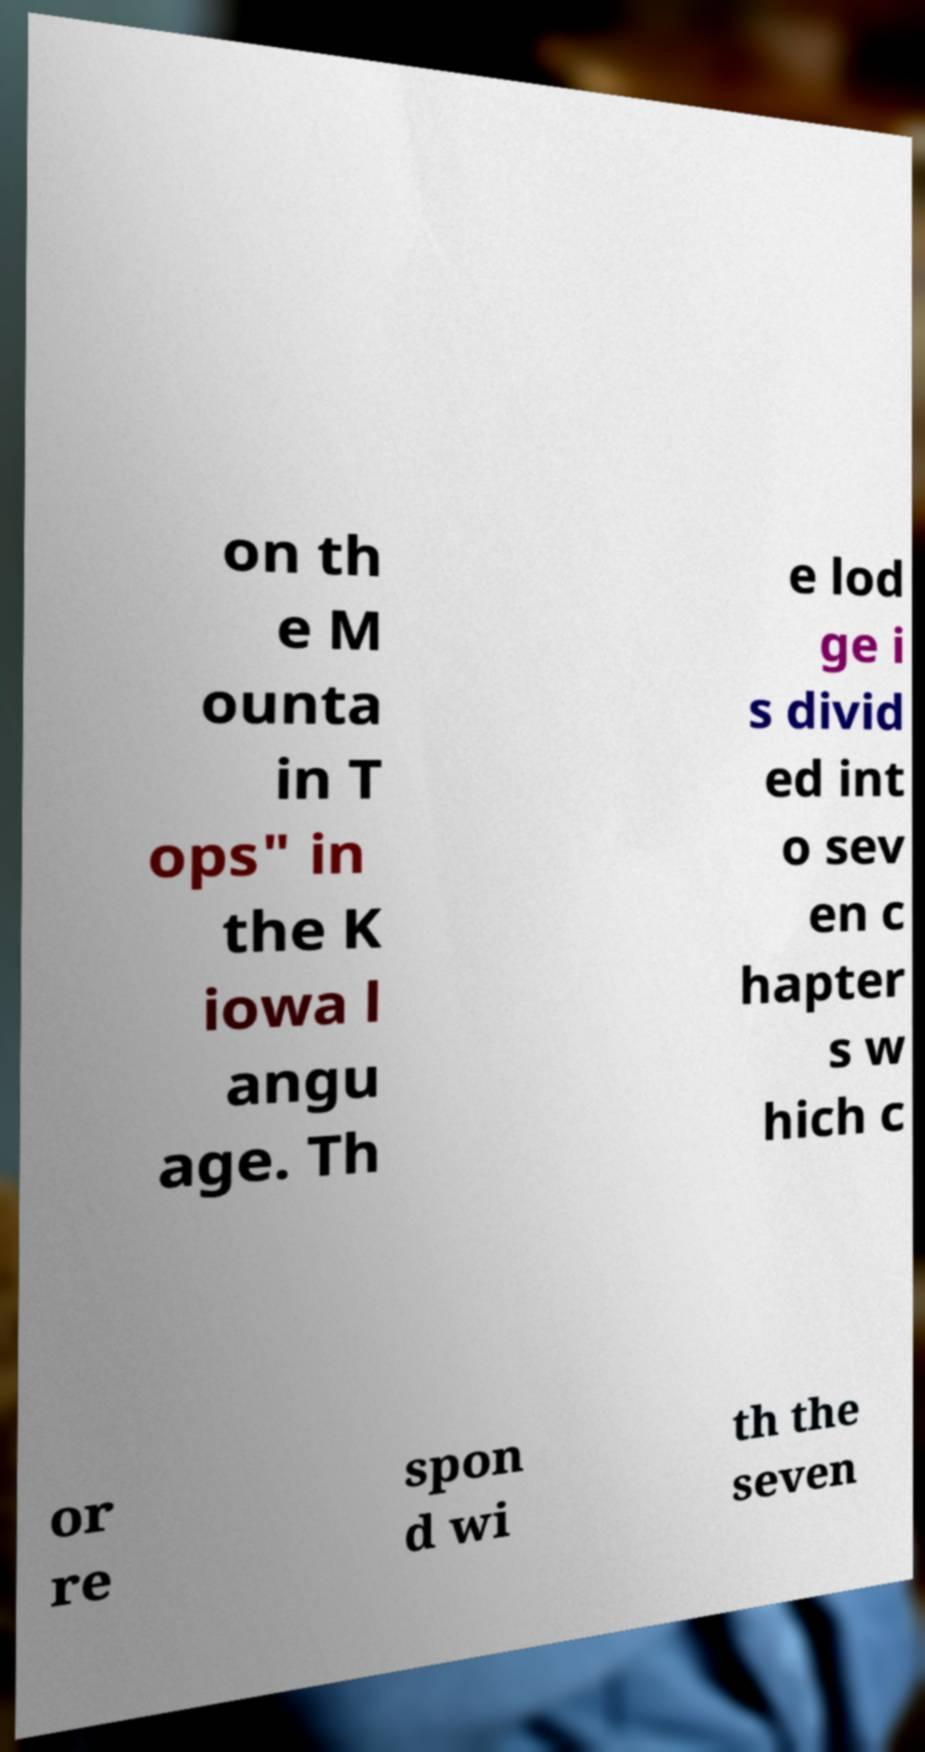Could you assist in decoding the text presented in this image and type it out clearly? on th e M ounta in T ops" in the K iowa l angu age. Th e lod ge i s divid ed int o sev en c hapter s w hich c or re spon d wi th the seven 